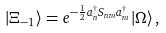Convert formula to latex. <formula><loc_0><loc_0><loc_500><loc_500>| \Xi _ { - 1 } \rangle = e ^ { - \frac { 1 } { 2 } a ^ { \dagger } _ { n } S _ { n m } a ^ { \dagger } _ { m } } | \Omega \rangle \, ,</formula> 